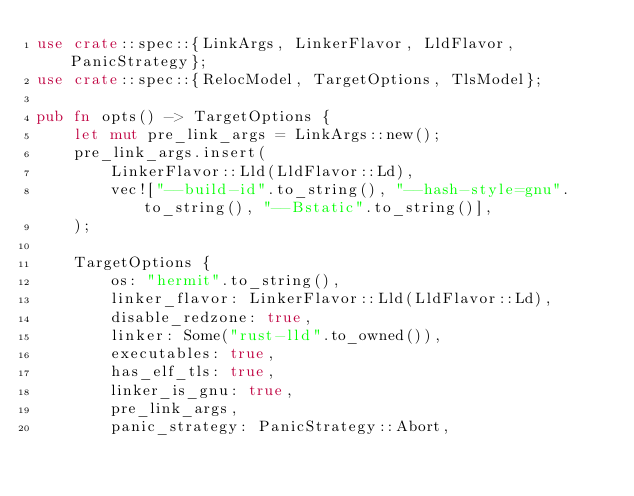<code> <loc_0><loc_0><loc_500><loc_500><_Rust_>use crate::spec::{LinkArgs, LinkerFlavor, LldFlavor, PanicStrategy};
use crate::spec::{RelocModel, TargetOptions, TlsModel};

pub fn opts() -> TargetOptions {
    let mut pre_link_args = LinkArgs::new();
    pre_link_args.insert(
        LinkerFlavor::Lld(LldFlavor::Ld),
        vec!["--build-id".to_string(), "--hash-style=gnu".to_string(), "--Bstatic".to_string()],
    );

    TargetOptions {
        os: "hermit".to_string(),
        linker_flavor: LinkerFlavor::Lld(LldFlavor::Ld),
        disable_redzone: true,
        linker: Some("rust-lld".to_owned()),
        executables: true,
        has_elf_tls: true,
        linker_is_gnu: true,
        pre_link_args,
        panic_strategy: PanicStrategy::Abort,</code> 